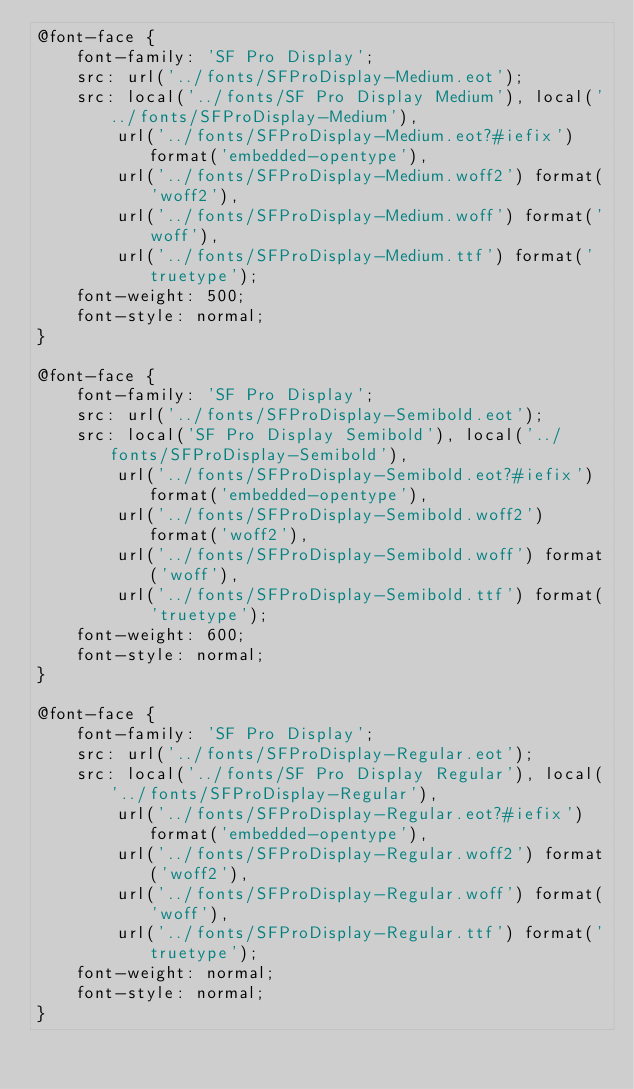<code> <loc_0><loc_0><loc_500><loc_500><_CSS_>@font-face {
    font-family: 'SF Pro Display';
    src: url('../fonts/SFProDisplay-Medium.eot');
    src: local('../fonts/SF Pro Display Medium'), local('../fonts/SFProDisplay-Medium'),
        url('../fonts/SFProDisplay-Medium.eot?#iefix') format('embedded-opentype'),
        url('../fonts/SFProDisplay-Medium.woff2') format('woff2'),
        url('../fonts/SFProDisplay-Medium.woff') format('woff'),
        url('../fonts/SFProDisplay-Medium.ttf') format('truetype');
    font-weight: 500;
    font-style: normal;
}

@font-face {
    font-family: 'SF Pro Display';
    src: url('../fonts/SFProDisplay-Semibold.eot');
    src: local('SF Pro Display Semibold'), local('../fonts/SFProDisplay-Semibold'),
        url('../fonts/SFProDisplay-Semibold.eot?#iefix') format('embedded-opentype'),
        url('../fonts/SFProDisplay-Semibold.woff2') format('woff2'),
        url('../fonts/SFProDisplay-Semibold.woff') format('woff'),
        url('../fonts/SFProDisplay-Semibold.ttf') format('truetype');
    font-weight: 600;
    font-style: normal;
}

@font-face {
    font-family: 'SF Pro Display';
    src: url('../fonts/SFProDisplay-Regular.eot');
    src: local('../fonts/SF Pro Display Regular'), local('../fonts/SFProDisplay-Regular'),
        url('../fonts/SFProDisplay-Regular.eot?#iefix') format('embedded-opentype'),
        url('../fonts/SFProDisplay-Regular.woff2') format('woff2'),
        url('../fonts/SFProDisplay-Regular.woff') format('woff'),
        url('../fonts/SFProDisplay-Regular.ttf') format('truetype');
    font-weight: normal;
    font-style: normal;
}

</code> 